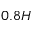Convert formula to latex. <formula><loc_0><loc_0><loc_500><loc_500>0 . 8 H</formula> 